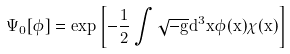Convert formula to latex. <formula><loc_0><loc_0><loc_500><loc_500>\Psi _ { 0 } [ \phi ] = e x p \left [ - \frac { 1 } { 2 } \int \sqrt { - g } d ^ { 3 } x \phi ( x ) \chi ( x ) \right ]</formula> 